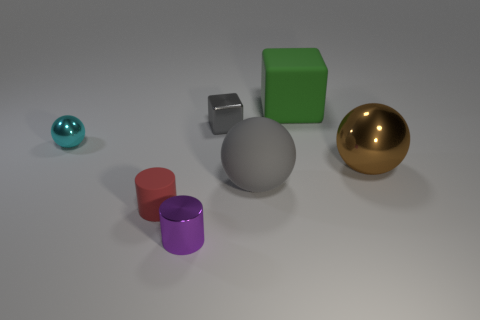Add 2 large red shiny spheres. How many objects exist? 9 Subtract all cylinders. How many objects are left? 5 Add 1 brown blocks. How many brown blocks exist? 1 Subtract 1 cyan balls. How many objects are left? 6 Subtract all small gray blocks. Subtract all gray cubes. How many objects are left? 5 Add 6 small blocks. How many small blocks are left? 7 